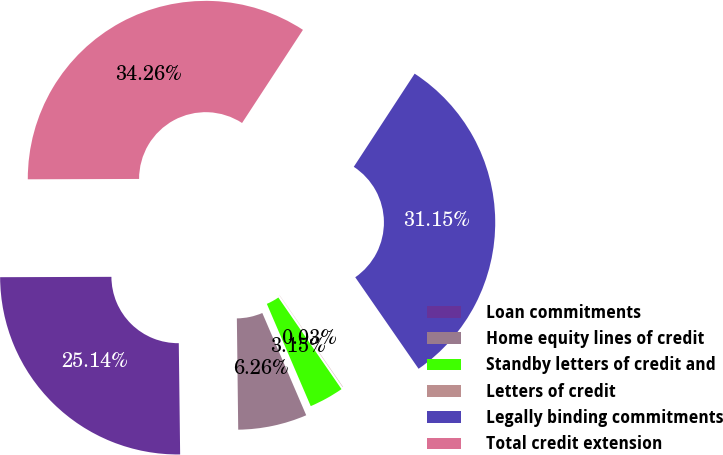Convert chart. <chart><loc_0><loc_0><loc_500><loc_500><pie_chart><fcel>Loan commitments<fcel>Home equity lines of credit<fcel>Standby letters of credit and<fcel>Letters of credit<fcel>Legally binding commitments<fcel>Total credit extension<nl><fcel>25.14%<fcel>6.26%<fcel>3.15%<fcel>0.03%<fcel>31.15%<fcel>34.26%<nl></chart> 